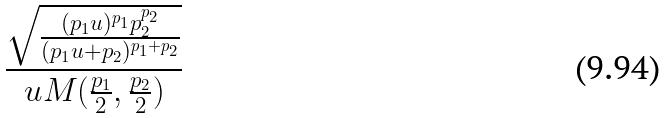Convert formula to latex. <formula><loc_0><loc_0><loc_500><loc_500>\frac { \sqrt { \frac { ( p _ { 1 } u ) ^ { p _ { 1 } } p _ { 2 } ^ { p _ { 2 } } } { ( p _ { 1 } u + p _ { 2 } ) ^ { p _ { 1 } + p _ { 2 } } } } } { u M ( \frac { p _ { 1 } } { 2 } , \frac { p _ { 2 } } { 2 } ) }</formula> 